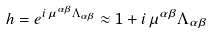Convert formula to latex. <formula><loc_0><loc_0><loc_500><loc_500>h = e ^ { i \, \mu ^ { \alpha \beta } \Lambda _ { \alpha \beta } } \approx 1 + i \, \mu ^ { \alpha \beta } \Lambda _ { \alpha \beta }</formula> 